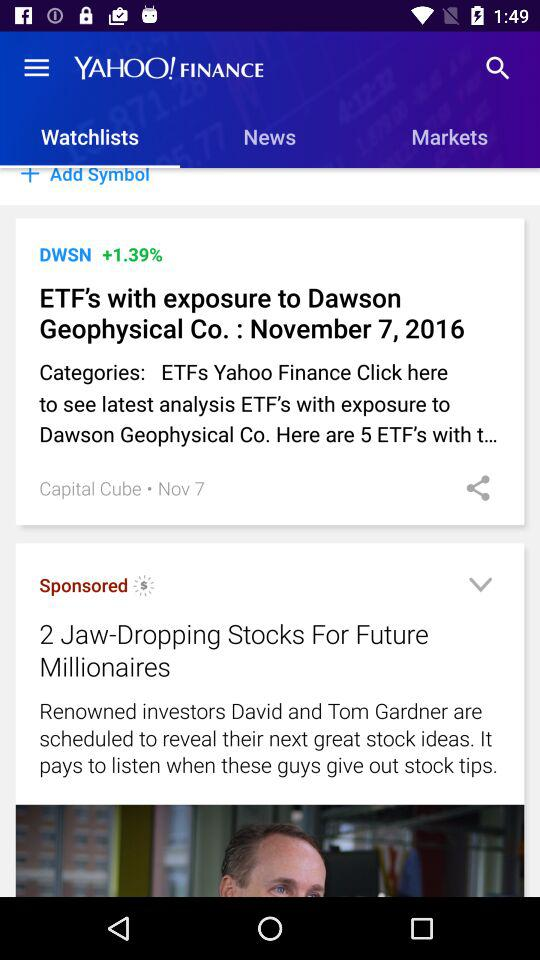On what date was "ETF's with exposure to Dawson Geophysical Co." posted in "Watchlists"? "ETF's with exposure to Dawson Geophysical Co." was posted in "Watchlists" on November 7. 